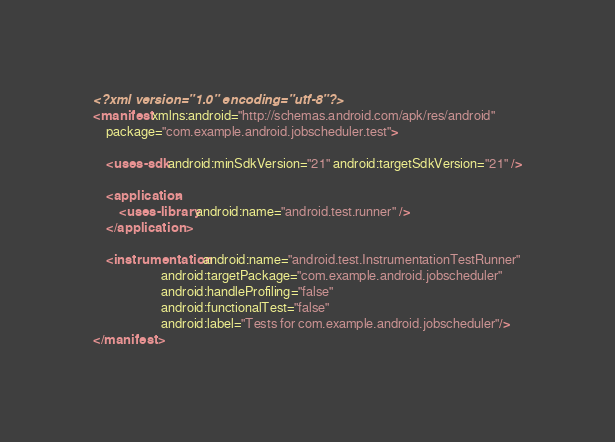Convert code to text. <code><loc_0><loc_0><loc_500><loc_500><_XML_><?xml version="1.0" encoding="utf-8"?>
<manifest xmlns:android="http://schemas.android.com/apk/res/android"
    package="com.example.android.jobscheduler.test">

    <uses-sdk android:minSdkVersion="21" android:targetSdkVersion="21" />

    <application>
        <uses-library android:name="android.test.runner" />
    </application>

    <instrumentation android:name="android.test.InstrumentationTestRunner"
                     android:targetPackage="com.example.android.jobscheduler"
                     android:handleProfiling="false"
                     android:functionalTest="false"
                     android:label="Tests for com.example.android.jobscheduler"/>
</manifest>
</code> 